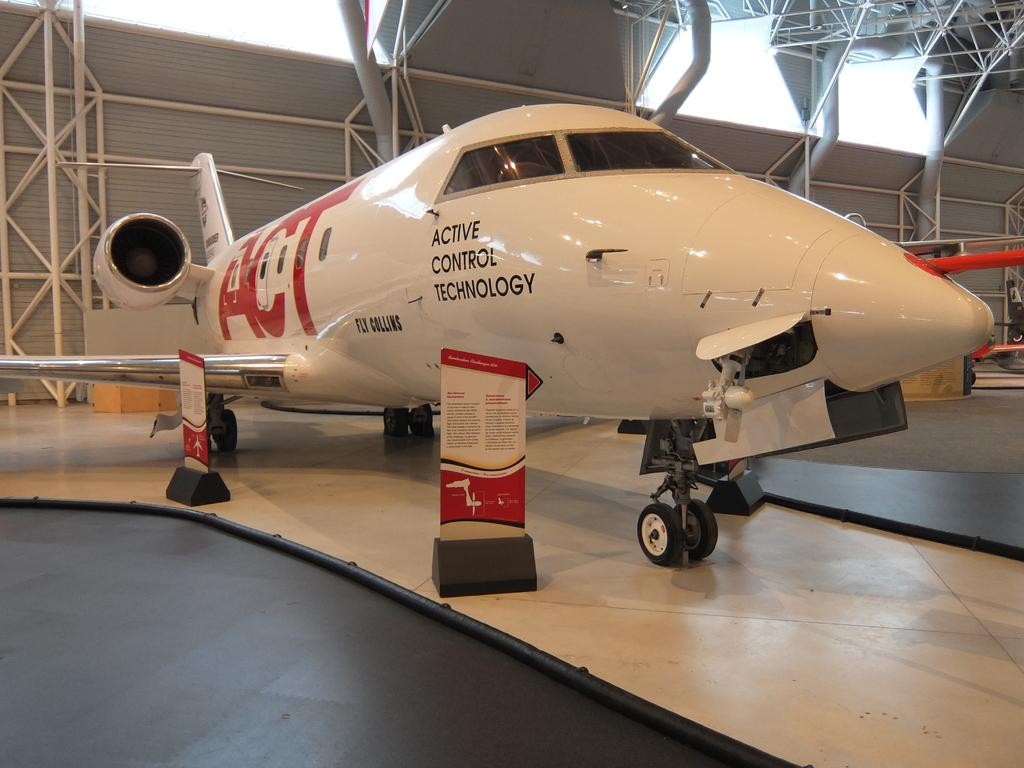<image>
Summarize the visual content of the image. hanger with plane inside that has active control technology on it and act in large red lettering 